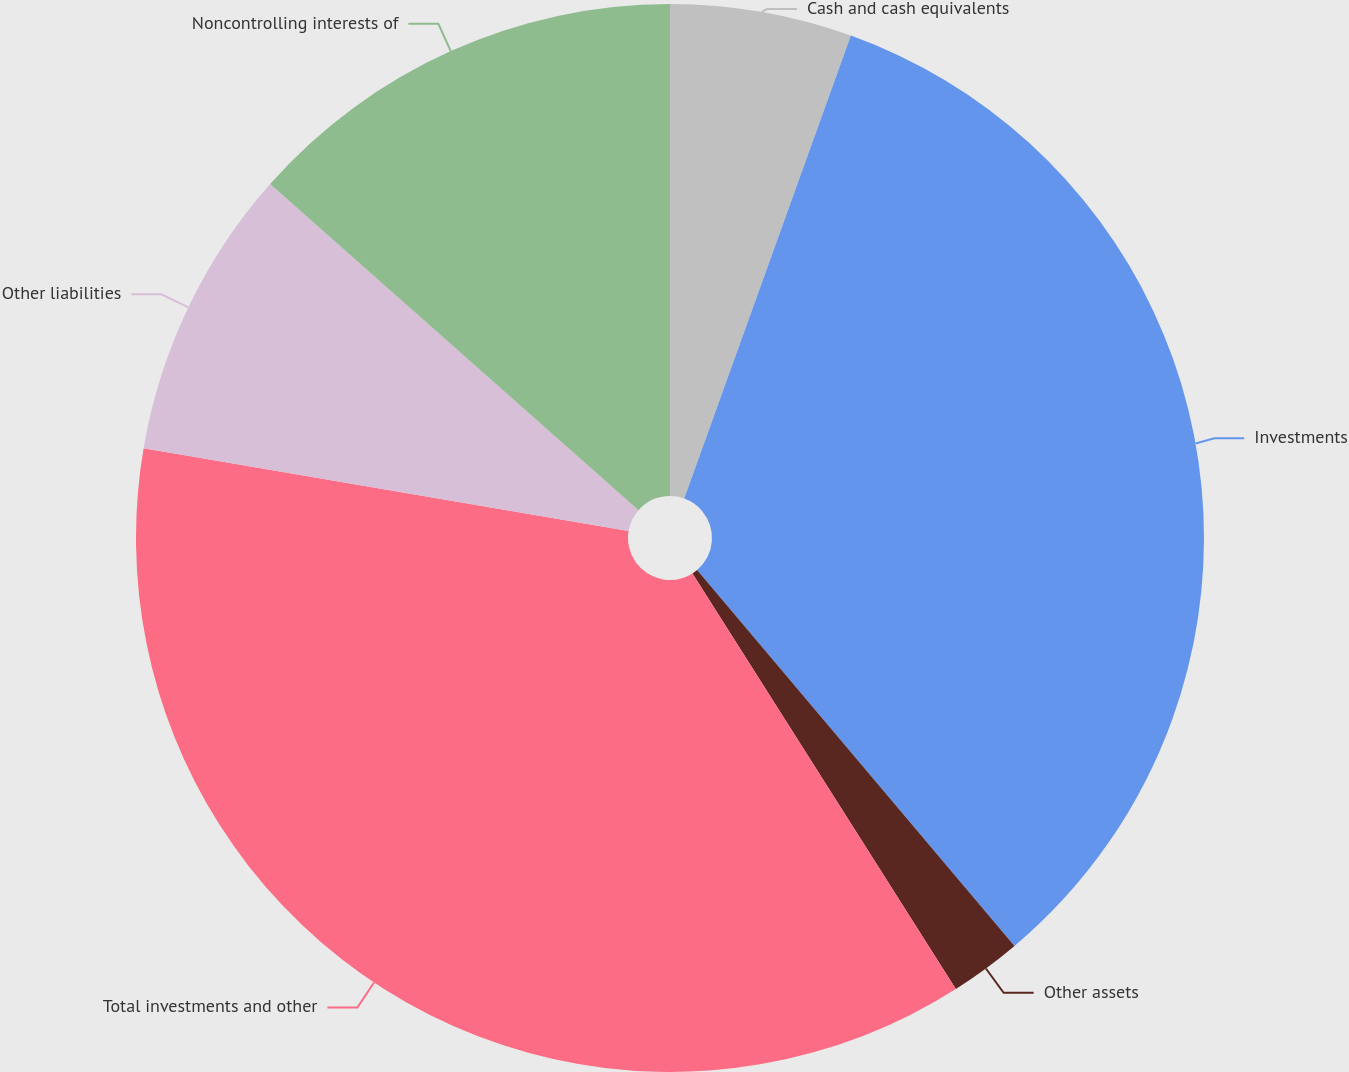Convert chart to OTSL. <chart><loc_0><loc_0><loc_500><loc_500><pie_chart><fcel>Cash and cash equivalents<fcel>Investments<fcel>Other assets<fcel>Total investments and other<fcel>Other liabilities<fcel>Noncontrolling interests of<nl><fcel>5.5%<fcel>33.34%<fcel>2.17%<fcel>36.68%<fcel>8.84%<fcel>13.47%<nl></chart> 